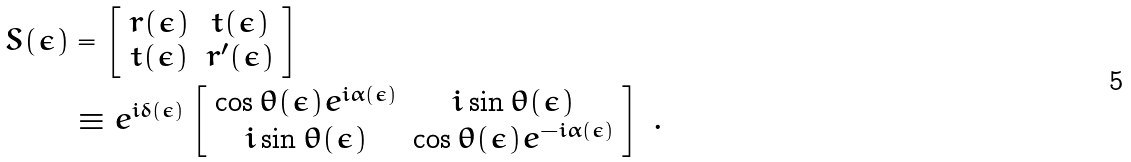<formula> <loc_0><loc_0><loc_500><loc_500>S ( \epsilon ) & = \left [ \begin{array} { c c } r ( \epsilon ) & t ( \epsilon ) \\ t ( \epsilon ) & r ^ { \prime } ( \epsilon ) \end{array} \right ] \\ & \equiv e ^ { i \delta ( \epsilon ) } \left [ \begin{array} { c c } \cos \theta ( \epsilon ) e ^ { i \alpha ( \epsilon ) } & i \sin \theta ( \epsilon ) \\ i \sin \theta ( \epsilon ) & \cos \theta ( \epsilon ) e ^ { - i \alpha ( \epsilon ) } \end{array} \right ] \ .</formula> 